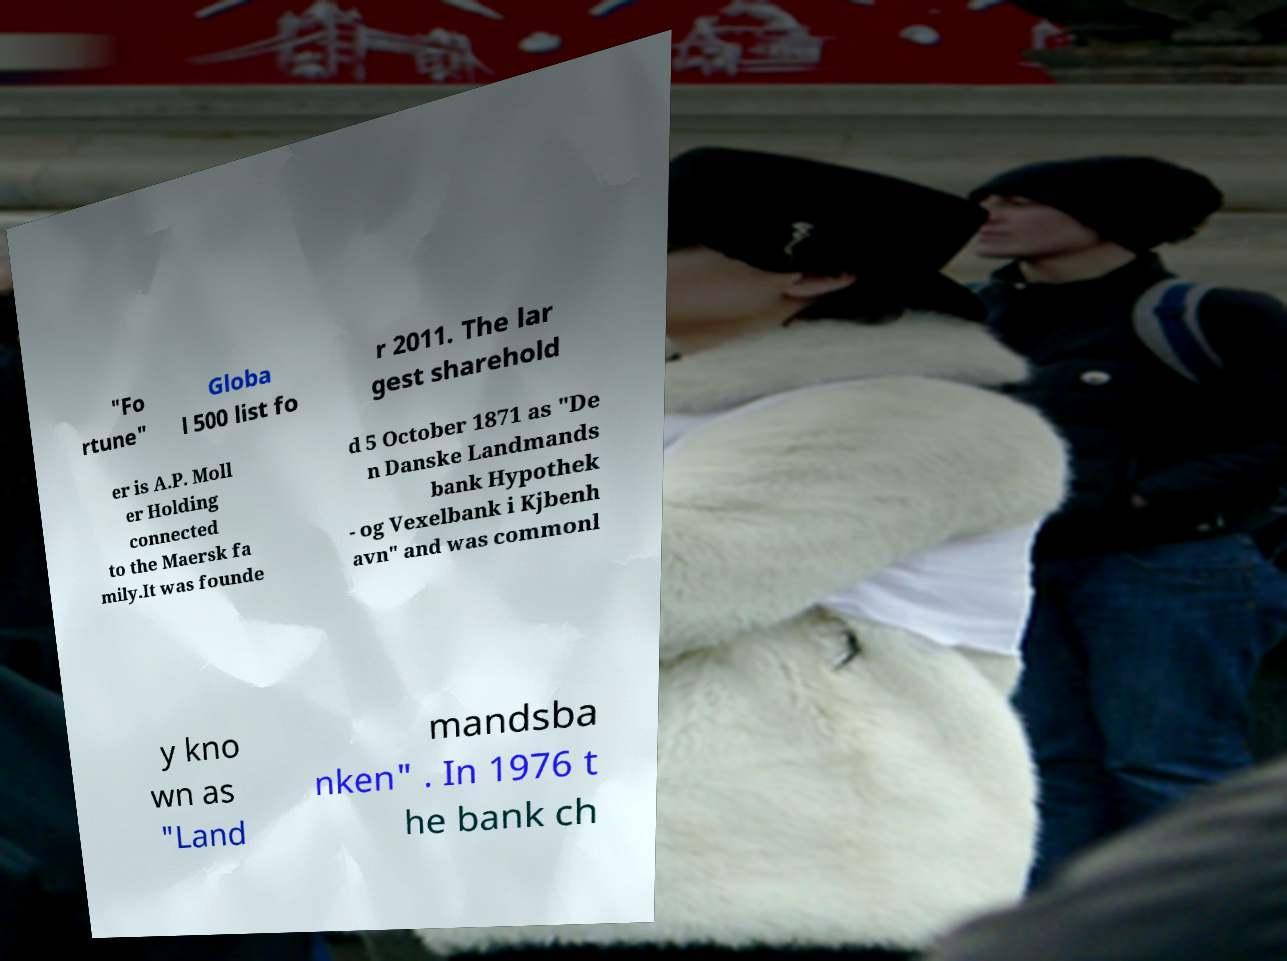Please identify and transcribe the text found in this image. "Fo rtune" Globa l 500 list fo r 2011. The lar gest sharehold er is A.P. Moll er Holding connected to the Maersk fa mily.It was founde d 5 October 1871 as "De n Danske Landmands bank Hypothek - og Vexelbank i Kjbenh avn" and was commonl y kno wn as "Land mandsba nken" . In 1976 t he bank ch 